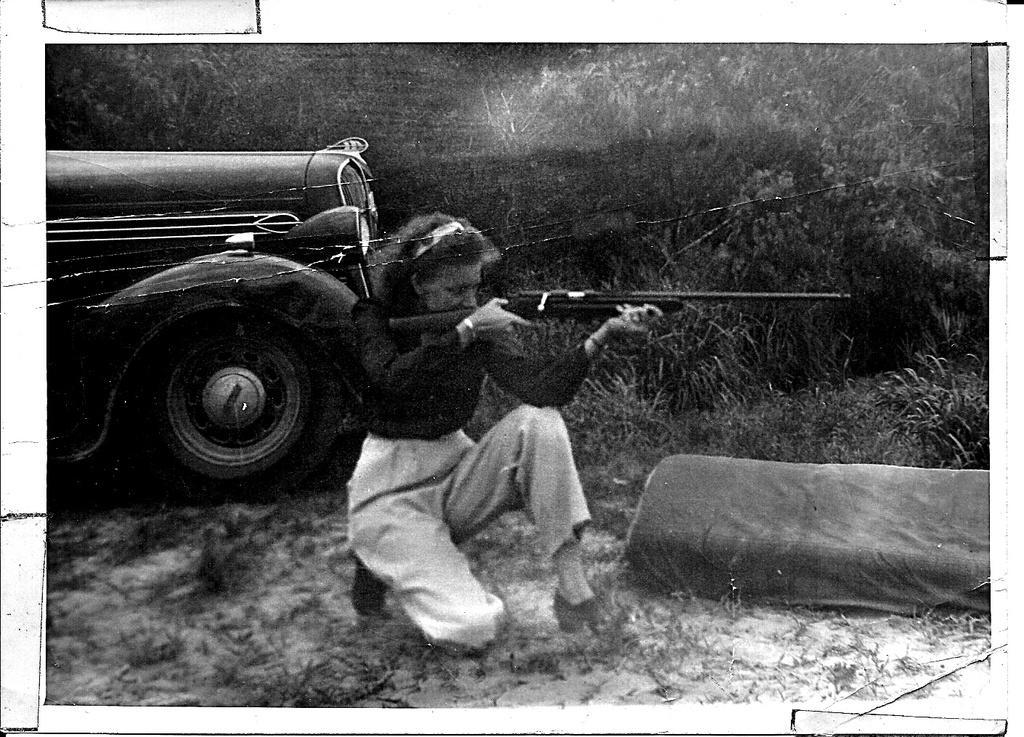Could you give a brief overview of what you see in this image? This is a black and white picture and in this picture we can see a woman holding a gun with her hands, vehicle, plants, cloth and in the background we can see trees. 